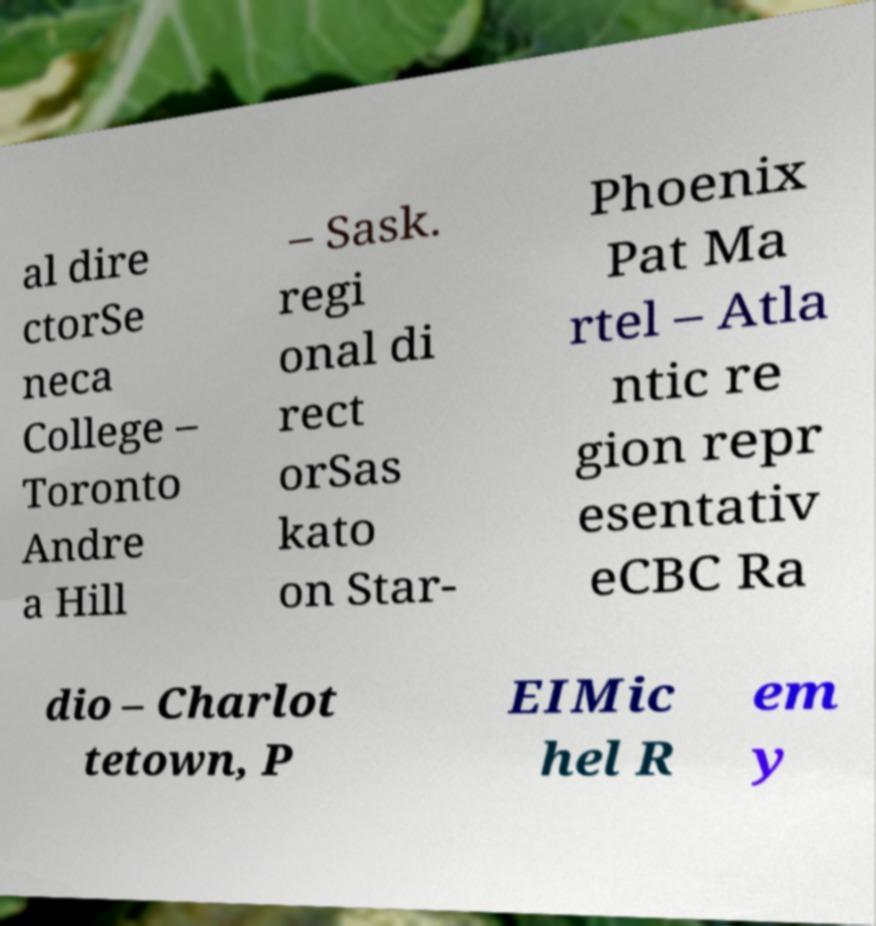Could you assist in decoding the text presented in this image and type it out clearly? al dire ctorSe neca College – Toronto Andre a Hill – Sask. regi onal di rect orSas kato on Star- Phoenix Pat Ma rtel – Atla ntic re gion repr esentativ eCBC Ra dio – Charlot tetown, P EIMic hel R em y 